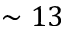<formula> <loc_0><loc_0><loc_500><loc_500>\sim 1 3</formula> 